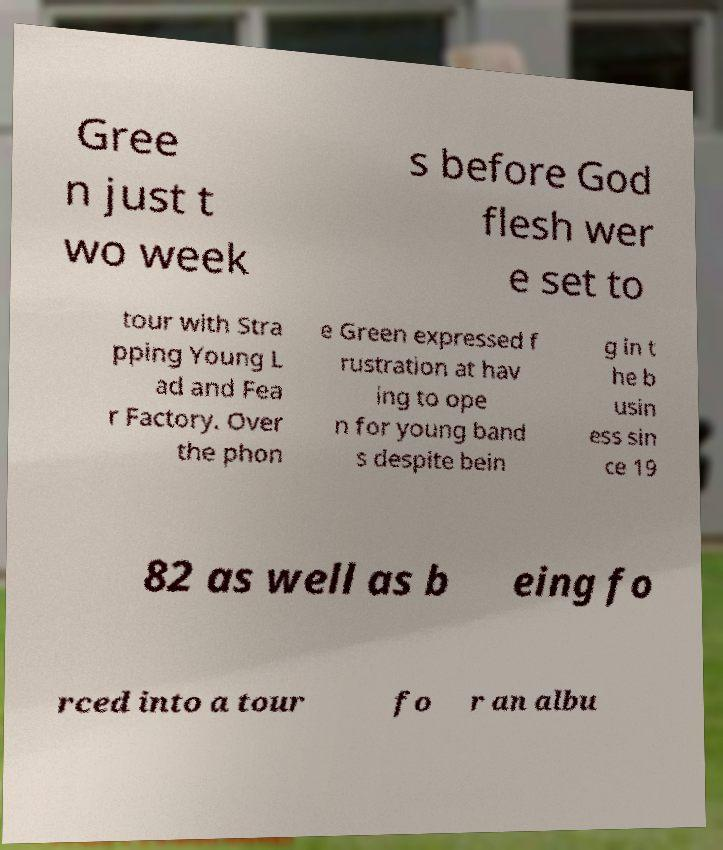For documentation purposes, I need the text within this image transcribed. Could you provide that? Gree n just t wo week s before God flesh wer e set to tour with Stra pping Young L ad and Fea r Factory. Over the phon e Green expressed f rustration at hav ing to ope n for young band s despite bein g in t he b usin ess sin ce 19 82 as well as b eing fo rced into a tour fo r an albu 